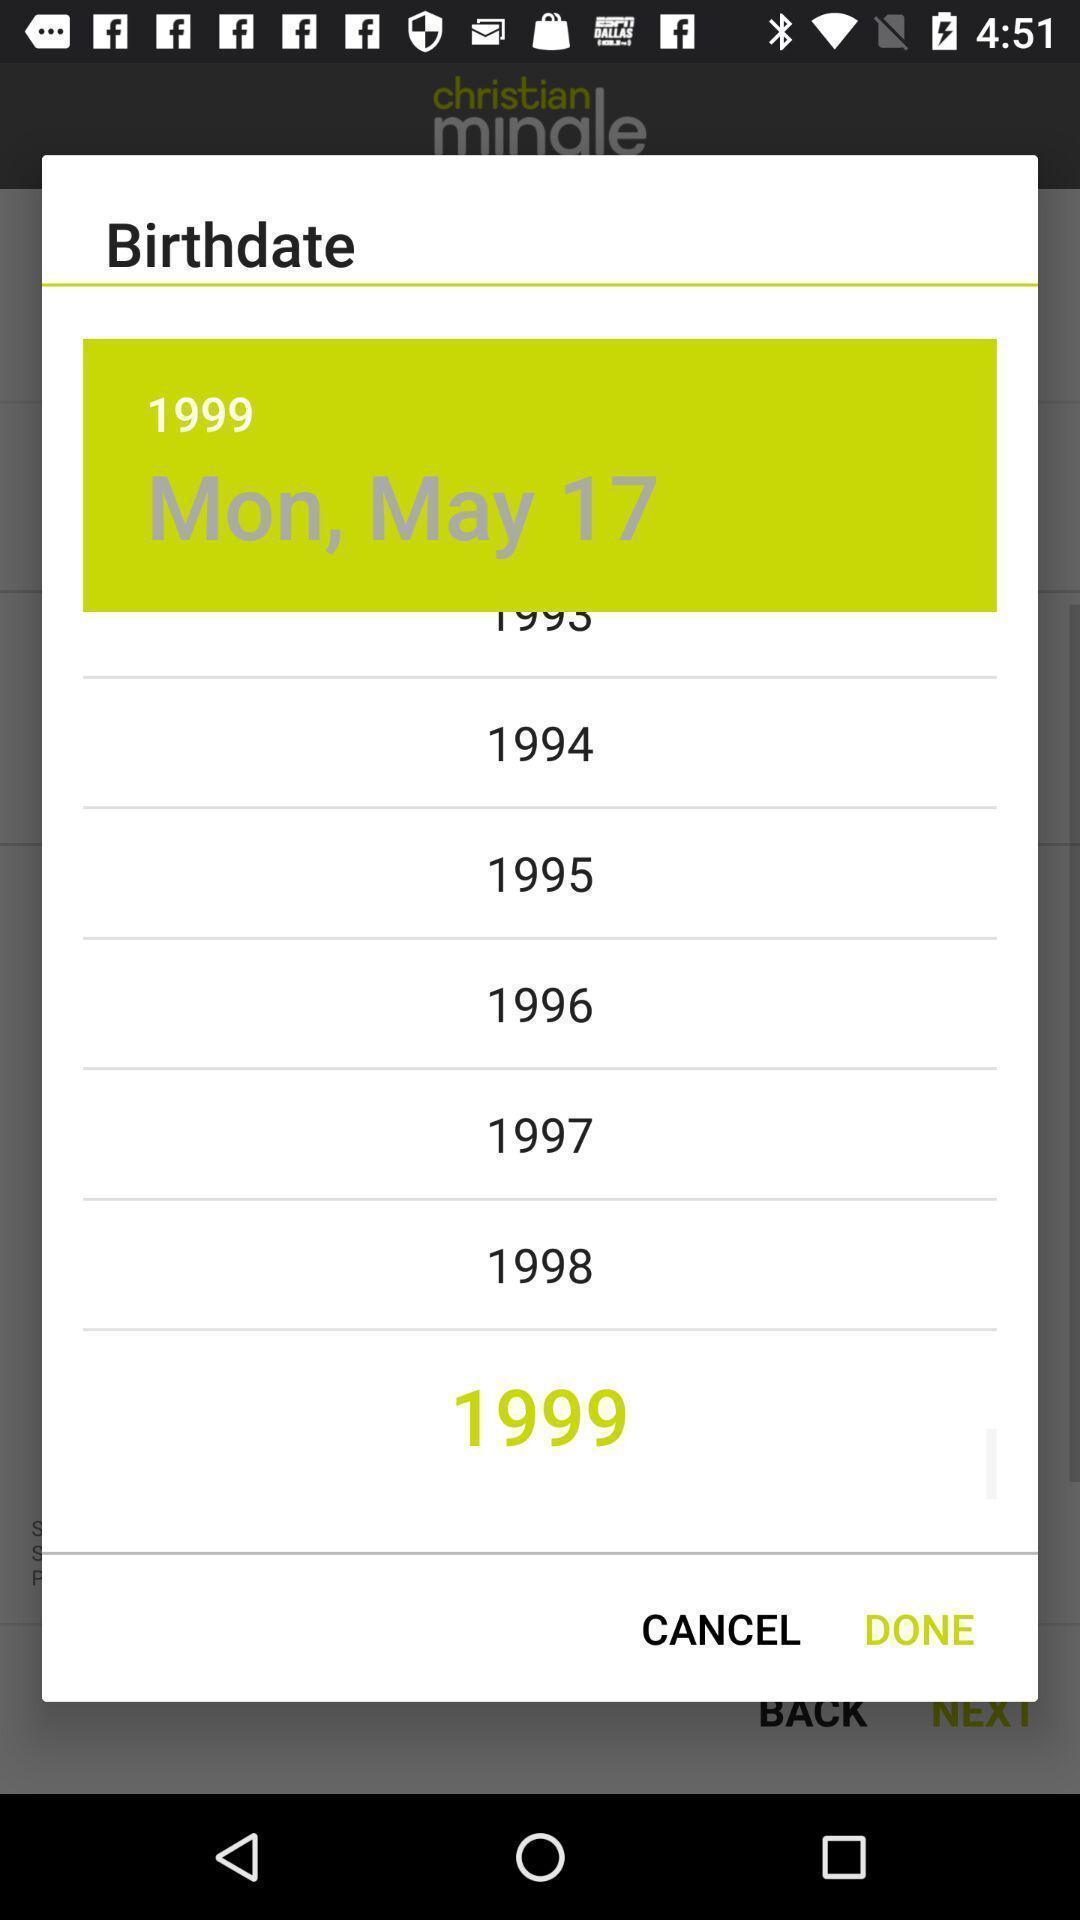Give me a narrative description of this picture. Pop-up shows to select birthdate. 